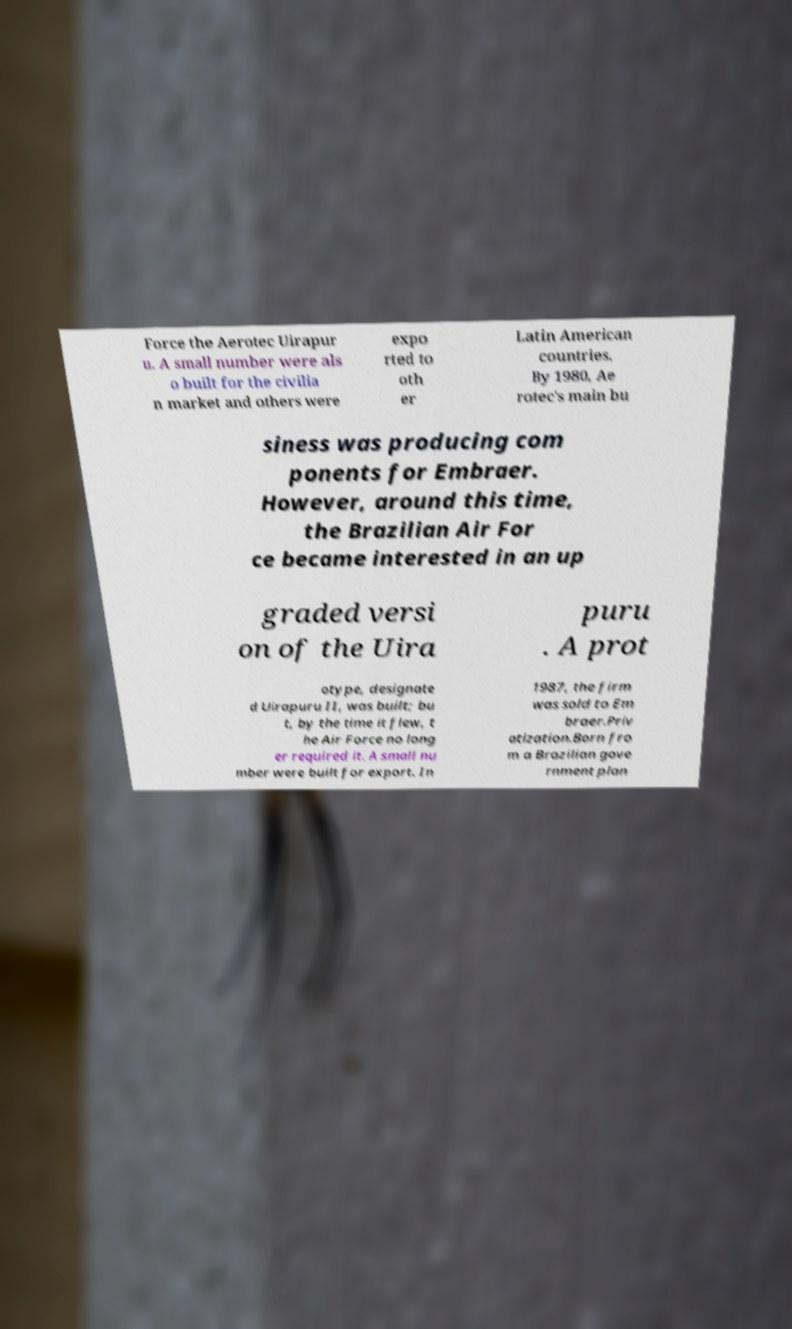There's text embedded in this image that I need extracted. Can you transcribe it verbatim? Force the Aerotec Uirapur u. A small number were als o built for the civilia n market and others were expo rted to oth er Latin American countries. By 1980, Ae rotec's main bu siness was producing com ponents for Embraer. However, around this time, the Brazilian Air For ce became interested in an up graded versi on of the Uira puru . A prot otype, designate d Uirapuru II, was built; bu t, by the time it flew, t he Air Force no long er required it. A small nu mber were built for export. In 1987, the firm was sold to Em braer.Priv atization.Born fro m a Brazilian gove rnment plan 